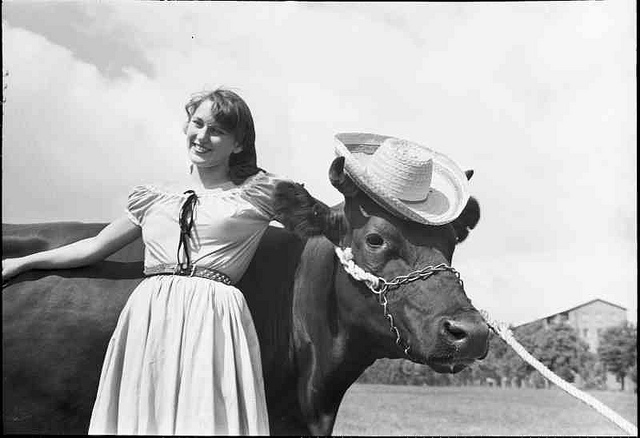<image>What year was this taken? It's ambiguous to determine the year the photo was taken. It could be somewhere between the 1930s and 1960s. What year was this taken? I don't know. It is unclear what year the image was taken. 